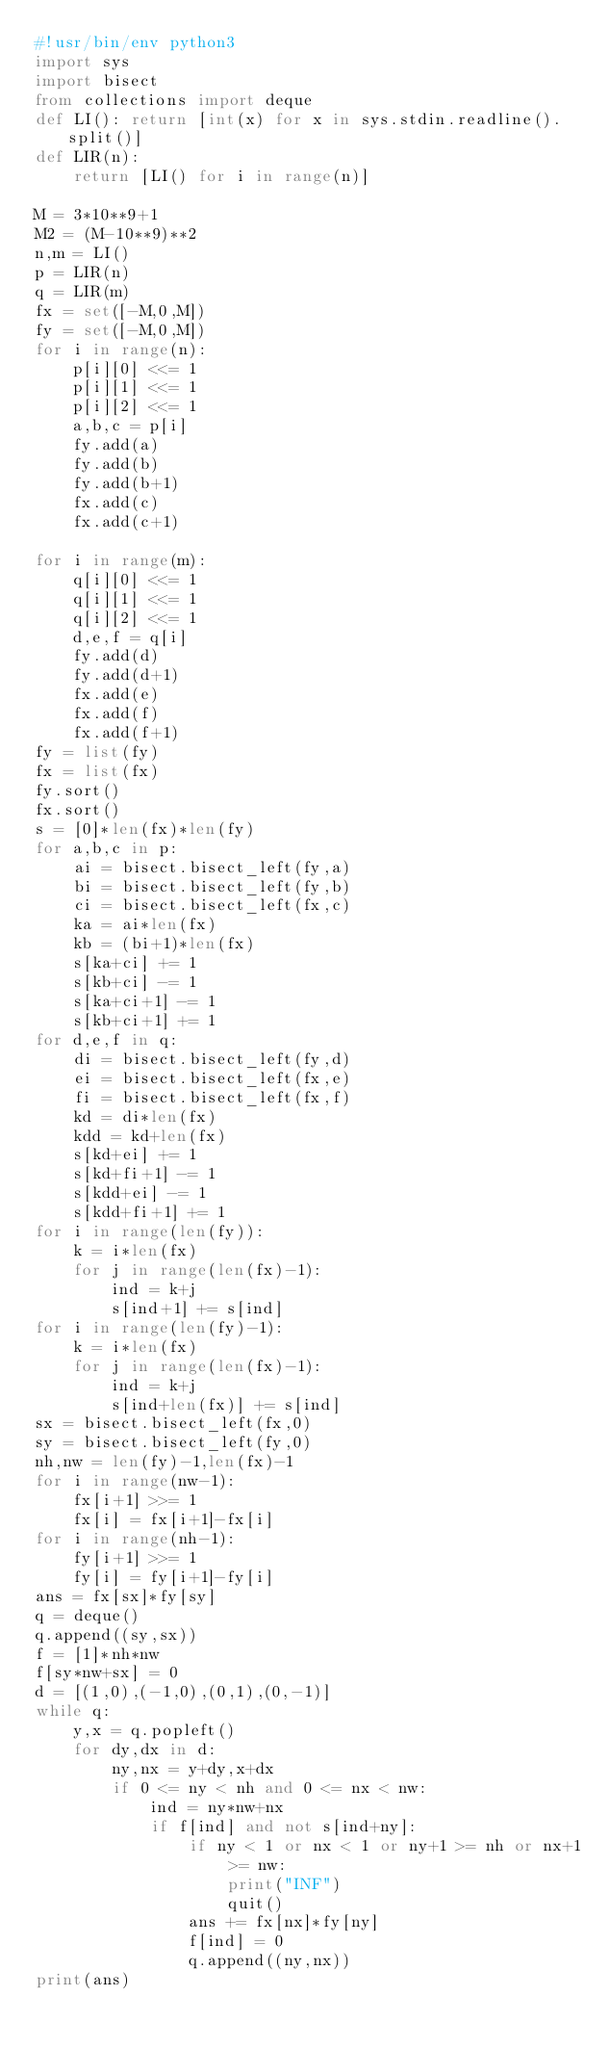Convert code to text. <code><loc_0><loc_0><loc_500><loc_500><_Python_>#!usr/bin/env python3
import sys
import bisect
from collections import deque
def LI(): return [int(x) for x in sys.stdin.readline().split()]
def LIR(n):
    return [LI() for i in range(n)]

M = 3*10**9+1
M2 = (M-10**9)**2
n,m = LI()
p = LIR(n)
q = LIR(m)
fx = set([-M,0,M])
fy = set([-M,0,M])
for i in range(n):
    p[i][0] <<= 1
    p[i][1] <<= 1
    p[i][2] <<= 1
    a,b,c = p[i]
    fy.add(a)
    fy.add(b)
    fy.add(b+1)
    fx.add(c)
    fx.add(c+1)

for i in range(m):
    q[i][0] <<= 1
    q[i][1] <<= 1
    q[i][2] <<= 1
    d,e,f = q[i]
    fy.add(d)
    fy.add(d+1)
    fx.add(e)
    fx.add(f)
    fx.add(f+1)
fy = list(fy)
fx = list(fx)
fy.sort()
fx.sort()
s = [0]*len(fx)*len(fy)
for a,b,c in p:
    ai = bisect.bisect_left(fy,a)
    bi = bisect.bisect_left(fy,b)
    ci = bisect.bisect_left(fx,c)
    ka = ai*len(fx)
    kb = (bi+1)*len(fx)
    s[ka+ci] += 1
    s[kb+ci] -= 1
    s[ka+ci+1] -= 1
    s[kb+ci+1] += 1
for d,e,f in q:
    di = bisect.bisect_left(fy,d)
    ei = bisect.bisect_left(fx,e)
    fi = bisect.bisect_left(fx,f)
    kd = di*len(fx)
    kdd = kd+len(fx)
    s[kd+ei] += 1
    s[kd+fi+1] -= 1
    s[kdd+ei] -= 1
    s[kdd+fi+1] += 1
for i in range(len(fy)):
    k = i*len(fx)
    for j in range(len(fx)-1):
        ind = k+j
        s[ind+1] += s[ind]
for i in range(len(fy)-1):
    k = i*len(fx)
    for j in range(len(fx)-1):
        ind = k+j
        s[ind+len(fx)] += s[ind]
sx = bisect.bisect_left(fx,0)
sy = bisect.bisect_left(fy,0)
nh,nw = len(fy)-1,len(fx)-1
for i in range(nw-1):
    fx[i+1] >>= 1
    fx[i] = fx[i+1]-fx[i]
for i in range(nh-1):
    fy[i+1] >>= 1
    fy[i] = fy[i+1]-fy[i]
ans = fx[sx]*fy[sy]
q = deque()
q.append((sy,sx))
f = [1]*nh*nw
f[sy*nw+sx] = 0
d = [(1,0),(-1,0),(0,1),(0,-1)]
while q:
    y,x = q.popleft()
    for dy,dx in d:
        ny,nx = y+dy,x+dx
        if 0 <= ny < nh and 0 <= nx < nw:
            ind = ny*nw+nx
            if f[ind] and not s[ind+ny]:
                if ny < 1 or nx < 1 or ny+1 >= nh or nx+1 >= nw:
                    print("INF")
                    quit()
                ans += fx[nx]*fy[ny]
                f[ind] = 0
                q.append((ny,nx))
print(ans)
</code> 